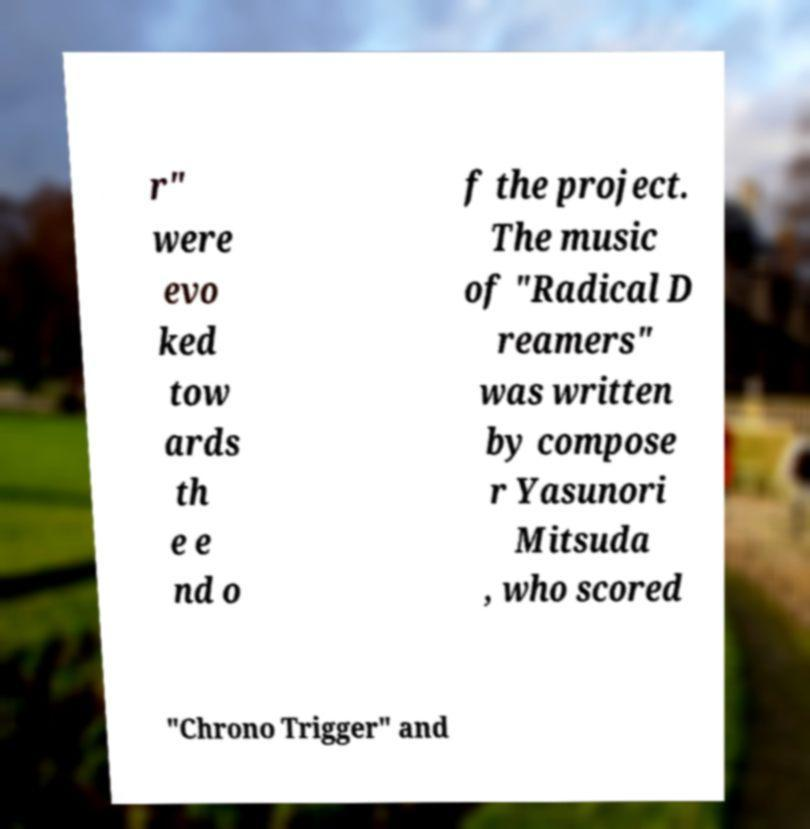Can you accurately transcribe the text from the provided image for me? r" were evo ked tow ards th e e nd o f the project. The music of "Radical D reamers" was written by compose r Yasunori Mitsuda , who scored "Chrono Trigger" and 